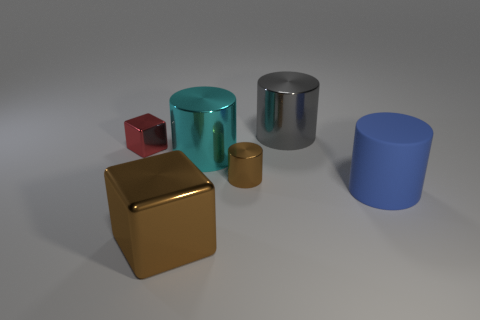Are there any other things that have the same material as the large blue cylinder?
Give a very brief answer. No. What number of blocks are tiny red objects or small things?
Offer a terse response. 1. Does the large cyan thing have the same material as the large block?
Ensure brevity in your answer.  Yes. There is another metallic thing that is the same shape as the large brown thing; what size is it?
Offer a very short reply. Small. There is a cylinder that is in front of the big cyan thing and left of the large matte object; what material is it made of?
Provide a short and direct response. Metal. Are there the same number of gray shiny objects right of the large blue rubber thing and small gray spheres?
Give a very brief answer. Yes. How many objects are either blocks that are to the right of the tiny red shiny cube or tiny yellow rubber cylinders?
Provide a short and direct response. 1. There is a big shiny object that is in front of the blue cylinder; is it the same color as the tiny cylinder?
Your answer should be compact. Yes. What size is the brown metal thing that is behind the big blue object?
Your answer should be very brief. Small. The tiny metallic thing that is right of the metal object in front of the rubber cylinder is what shape?
Your answer should be compact. Cylinder. 